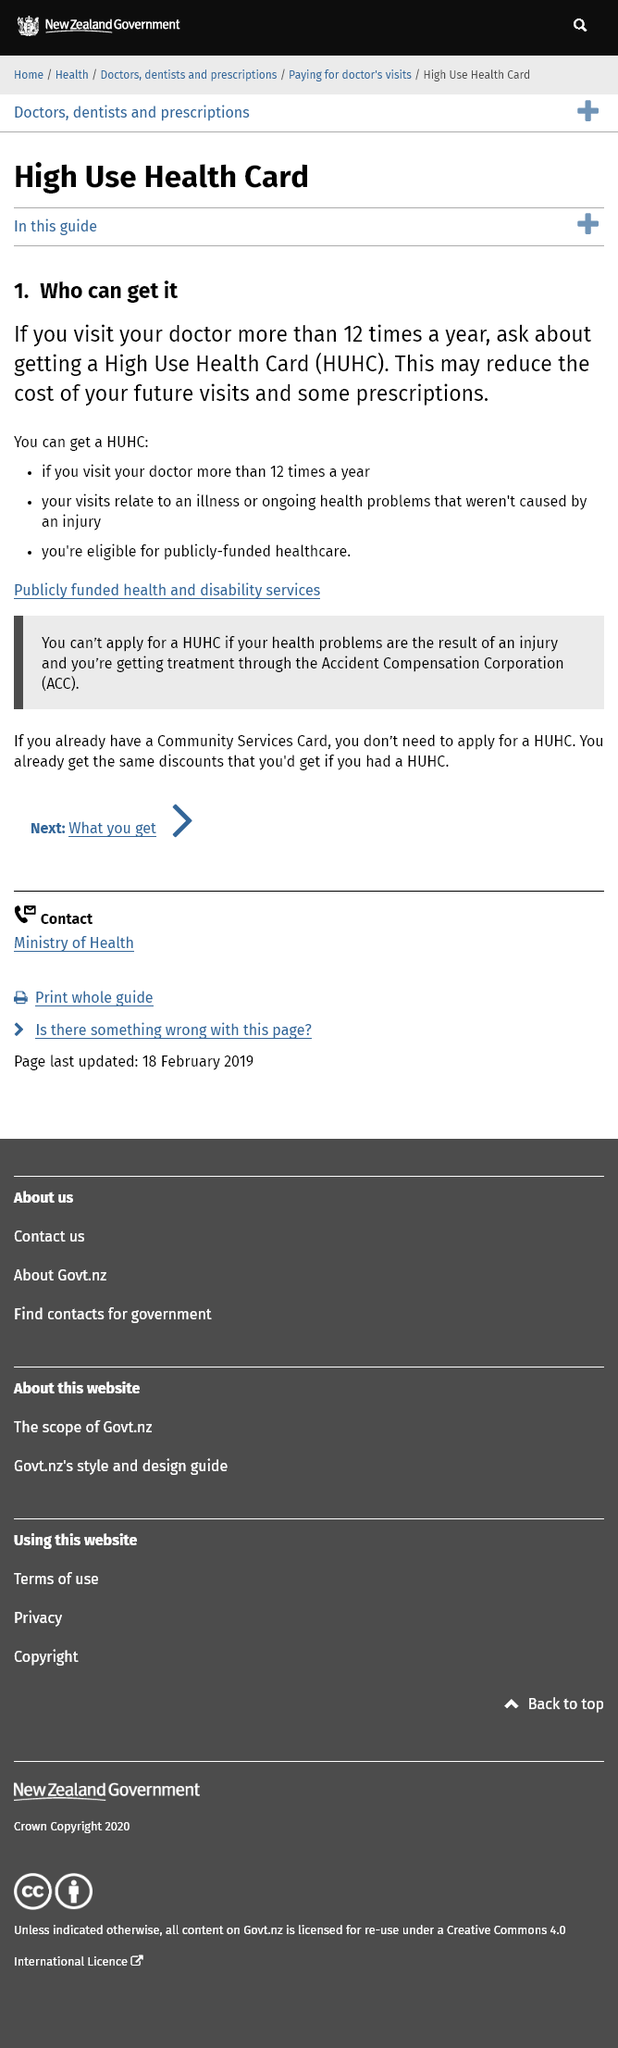Indicate a few pertinent items in this graphic. It is necessary to visit the doctor more than 12 times per year in order to receive a Health Utilization and Health Care Cost (HUHC) report. It is not possible to apply for a High Use Health Card if your health problems are a result of an injury and you are currently receiving treatment through the Accident Compensation Corporation. The benefit of this is that it may reduce the cost of future visits and some prescriptions. 